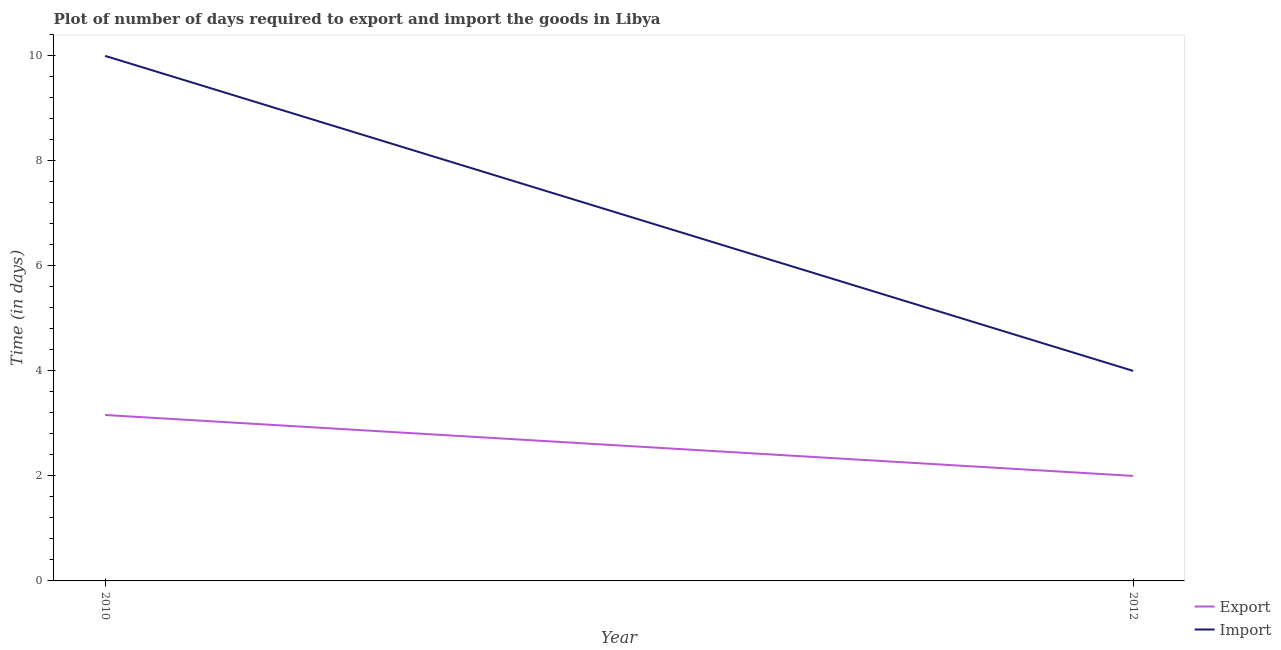How many different coloured lines are there?
Ensure brevity in your answer.  2. Does the line corresponding to time required to export intersect with the line corresponding to time required to import?
Your response must be concise. No. Across all years, what is the maximum time required to import?
Offer a terse response. 10. What is the total time required to export in the graph?
Make the answer very short. 5.16. What is the difference between the time required to export in 2010 and that in 2012?
Your answer should be very brief. 1.16. What is the difference between the time required to import in 2012 and the time required to export in 2010?
Provide a succinct answer. 0.84. What is the average time required to export per year?
Keep it short and to the point. 2.58. In the year 2012, what is the difference between the time required to export and time required to import?
Offer a terse response. -2. What is the ratio of the time required to export in 2010 to that in 2012?
Make the answer very short. 1.58. Is the time required to import in 2010 less than that in 2012?
Offer a very short reply. No. In how many years, is the time required to export greater than the average time required to export taken over all years?
Provide a short and direct response. 1. Is the time required to export strictly less than the time required to import over the years?
Your response must be concise. Yes. How many lines are there?
Keep it short and to the point. 2. How many years are there in the graph?
Your answer should be compact. 2. How many legend labels are there?
Ensure brevity in your answer.  2. How are the legend labels stacked?
Provide a succinct answer. Vertical. What is the title of the graph?
Provide a short and direct response. Plot of number of days required to export and import the goods in Libya. What is the label or title of the X-axis?
Your response must be concise. Year. What is the label or title of the Y-axis?
Provide a succinct answer. Time (in days). What is the Time (in days) in Export in 2010?
Keep it short and to the point. 3.16. What is the Time (in days) of Import in 2012?
Provide a succinct answer. 4. Across all years, what is the maximum Time (in days) of Export?
Offer a terse response. 3.16. What is the total Time (in days) of Export in the graph?
Provide a succinct answer. 5.16. What is the total Time (in days) in Import in the graph?
Your response must be concise. 14. What is the difference between the Time (in days) of Export in 2010 and that in 2012?
Provide a succinct answer. 1.16. What is the difference between the Time (in days) in Export in 2010 and the Time (in days) in Import in 2012?
Ensure brevity in your answer.  -0.84. What is the average Time (in days) in Export per year?
Provide a short and direct response. 2.58. What is the average Time (in days) of Import per year?
Offer a terse response. 7. In the year 2010, what is the difference between the Time (in days) in Export and Time (in days) in Import?
Give a very brief answer. -6.84. In the year 2012, what is the difference between the Time (in days) in Export and Time (in days) in Import?
Provide a succinct answer. -2. What is the ratio of the Time (in days) in Export in 2010 to that in 2012?
Your answer should be very brief. 1.58. What is the difference between the highest and the second highest Time (in days) of Export?
Your answer should be compact. 1.16. What is the difference between the highest and the second highest Time (in days) of Import?
Provide a short and direct response. 6. What is the difference between the highest and the lowest Time (in days) of Export?
Your answer should be compact. 1.16. 